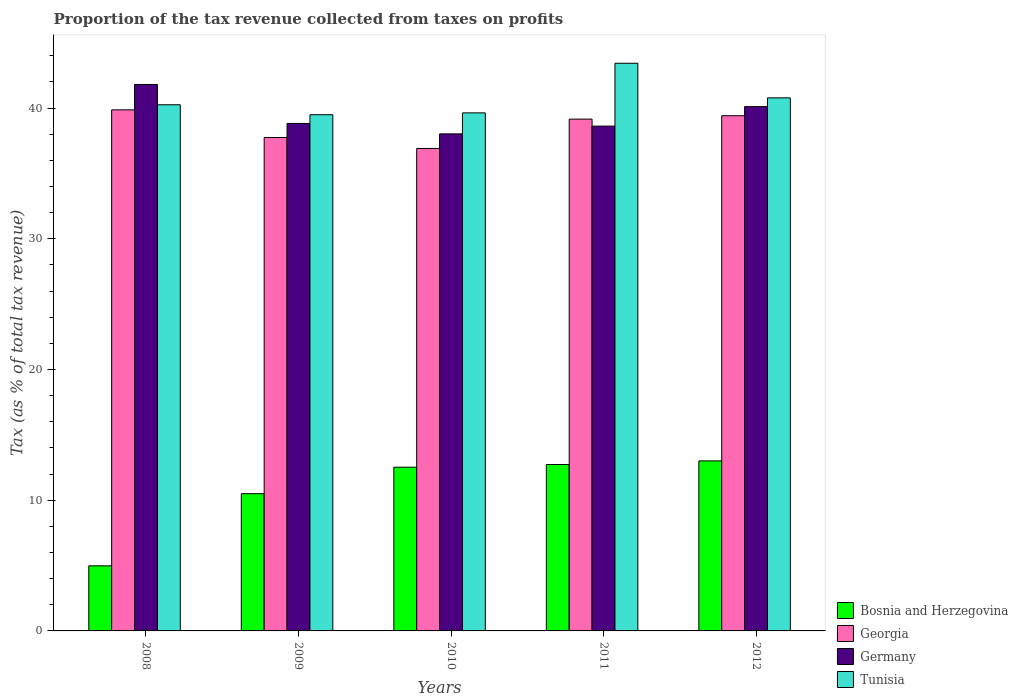How many bars are there on the 5th tick from the left?
Provide a short and direct response. 4. What is the label of the 2nd group of bars from the left?
Offer a terse response. 2009. What is the proportion of the tax revenue collected in Georgia in 2011?
Provide a short and direct response. 39.15. Across all years, what is the maximum proportion of the tax revenue collected in Georgia?
Make the answer very short. 39.86. Across all years, what is the minimum proportion of the tax revenue collected in Georgia?
Make the answer very short. 36.91. What is the total proportion of the tax revenue collected in Bosnia and Herzegovina in the graph?
Your answer should be very brief. 53.74. What is the difference between the proportion of the tax revenue collected in Tunisia in 2008 and that in 2009?
Your answer should be compact. 0.76. What is the difference between the proportion of the tax revenue collected in Georgia in 2008 and the proportion of the tax revenue collected in Tunisia in 2012?
Your answer should be very brief. -0.92. What is the average proportion of the tax revenue collected in Germany per year?
Make the answer very short. 39.48. In the year 2012, what is the difference between the proportion of the tax revenue collected in Georgia and proportion of the tax revenue collected in Bosnia and Herzegovina?
Give a very brief answer. 26.41. What is the ratio of the proportion of the tax revenue collected in Germany in 2009 to that in 2011?
Your answer should be very brief. 1.01. Is the proportion of the tax revenue collected in Georgia in 2008 less than that in 2009?
Your answer should be compact. No. Is the difference between the proportion of the tax revenue collected in Georgia in 2008 and 2011 greater than the difference between the proportion of the tax revenue collected in Bosnia and Herzegovina in 2008 and 2011?
Keep it short and to the point. Yes. What is the difference between the highest and the second highest proportion of the tax revenue collected in Tunisia?
Keep it short and to the point. 2.65. What is the difference between the highest and the lowest proportion of the tax revenue collected in Germany?
Keep it short and to the point. 3.78. In how many years, is the proportion of the tax revenue collected in Germany greater than the average proportion of the tax revenue collected in Germany taken over all years?
Make the answer very short. 2. What does the 3rd bar from the left in 2011 represents?
Your answer should be compact. Germany. What does the 1st bar from the right in 2012 represents?
Make the answer very short. Tunisia. Are all the bars in the graph horizontal?
Your response must be concise. No. Does the graph contain grids?
Offer a very short reply. No. How many legend labels are there?
Offer a terse response. 4. What is the title of the graph?
Your answer should be compact. Proportion of the tax revenue collected from taxes on profits. What is the label or title of the X-axis?
Your answer should be very brief. Years. What is the label or title of the Y-axis?
Offer a terse response. Tax (as % of total tax revenue). What is the Tax (as % of total tax revenue) in Bosnia and Herzegovina in 2008?
Ensure brevity in your answer.  4.98. What is the Tax (as % of total tax revenue) of Georgia in 2008?
Your answer should be very brief. 39.86. What is the Tax (as % of total tax revenue) of Germany in 2008?
Your response must be concise. 41.8. What is the Tax (as % of total tax revenue) of Tunisia in 2008?
Provide a short and direct response. 40.25. What is the Tax (as % of total tax revenue) in Bosnia and Herzegovina in 2009?
Your answer should be compact. 10.5. What is the Tax (as % of total tax revenue) in Georgia in 2009?
Provide a short and direct response. 37.75. What is the Tax (as % of total tax revenue) of Germany in 2009?
Ensure brevity in your answer.  38.82. What is the Tax (as % of total tax revenue) in Tunisia in 2009?
Keep it short and to the point. 39.49. What is the Tax (as % of total tax revenue) in Bosnia and Herzegovina in 2010?
Offer a very short reply. 12.52. What is the Tax (as % of total tax revenue) of Georgia in 2010?
Offer a terse response. 36.91. What is the Tax (as % of total tax revenue) of Germany in 2010?
Offer a very short reply. 38.03. What is the Tax (as % of total tax revenue) in Tunisia in 2010?
Your answer should be compact. 39.63. What is the Tax (as % of total tax revenue) of Bosnia and Herzegovina in 2011?
Your answer should be compact. 12.73. What is the Tax (as % of total tax revenue) in Georgia in 2011?
Ensure brevity in your answer.  39.15. What is the Tax (as % of total tax revenue) of Germany in 2011?
Provide a short and direct response. 38.62. What is the Tax (as % of total tax revenue) of Tunisia in 2011?
Provide a short and direct response. 43.43. What is the Tax (as % of total tax revenue) in Bosnia and Herzegovina in 2012?
Your answer should be very brief. 13.01. What is the Tax (as % of total tax revenue) of Georgia in 2012?
Make the answer very short. 39.41. What is the Tax (as % of total tax revenue) in Germany in 2012?
Your response must be concise. 40.11. What is the Tax (as % of total tax revenue) in Tunisia in 2012?
Your answer should be compact. 40.78. Across all years, what is the maximum Tax (as % of total tax revenue) in Bosnia and Herzegovina?
Offer a very short reply. 13.01. Across all years, what is the maximum Tax (as % of total tax revenue) in Georgia?
Offer a very short reply. 39.86. Across all years, what is the maximum Tax (as % of total tax revenue) of Germany?
Keep it short and to the point. 41.8. Across all years, what is the maximum Tax (as % of total tax revenue) of Tunisia?
Give a very brief answer. 43.43. Across all years, what is the minimum Tax (as % of total tax revenue) in Bosnia and Herzegovina?
Your answer should be very brief. 4.98. Across all years, what is the minimum Tax (as % of total tax revenue) in Georgia?
Provide a short and direct response. 36.91. Across all years, what is the minimum Tax (as % of total tax revenue) of Germany?
Provide a short and direct response. 38.03. Across all years, what is the minimum Tax (as % of total tax revenue) in Tunisia?
Ensure brevity in your answer.  39.49. What is the total Tax (as % of total tax revenue) of Bosnia and Herzegovina in the graph?
Make the answer very short. 53.74. What is the total Tax (as % of total tax revenue) in Georgia in the graph?
Provide a succinct answer. 193.08. What is the total Tax (as % of total tax revenue) in Germany in the graph?
Offer a terse response. 197.38. What is the total Tax (as % of total tax revenue) in Tunisia in the graph?
Your answer should be compact. 203.58. What is the difference between the Tax (as % of total tax revenue) in Bosnia and Herzegovina in 2008 and that in 2009?
Provide a succinct answer. -5.52. What is the difference between the Tax (as % of total tax revenue) of Georgia in 2008 and that in 2009?
Give a very brief answer. 2.12. What is the difference between the Tax (as % of total tax revenue) in Germany in 2008 and that in 2009?
Offer a very short reply. 2.98. What is the difference between the Tax (as % of total tax revenue) in Tunisia in 2008 and that in 2009?
Provide a short and direct response. 0.76. What is the difference between the Tax (as % of total tax revenue) in Bosnia and Herzegovina in 2008 and that in 2010?
Your answer should be compact. -7.54. What is the difference between the Tax (as % of total tax revenue) in Georgia in 2008 and that in 2010?
Your response must be concise. 2.95. What is the difference between the Tax (as % of total tax revenue) of Germany in 2008 and that in 2010?
Ensure brevity in your answer.  3.78. What is the difference between the Tax (as % of total tax revenue) in Tunisia in 2008 and that in 2010?
Your answer should be compact. 0.62. What is the difference between the Tax (as % of total tax revenue) of Bosnia and Herzegovina in 2008 and that in 2011?
Give a very brief answer. -7.75. What is the difference between the Tax (as % of total tax revenue) of Georgia in 2008 and that in 2011?
Offer a terse response. 0.71. What is the difference between the Tax (as % of total tax revenue) in Germany in 2008 and that in 2011?
Your answer should be very brief. 3.19. What is the difference between the Tax (as % of total tax revenue) of Tunisia in 2008 and that in 2011?
Your response must be concise. -3.18. What is the difference between the Tax (as % of total tax revenue) in Bosnia and Herzegovina in 2008 and that in 2012?
Give a very brief answer. -8.03. What is the difference between the Tax (as % of total tax revenue) of Georgia in 2008 and that in 2012?
Give a very brief answer. 0.45. What is the difference between the Tax (as % of total tax revenue) in Germany in 2008 and that in 2012?
Provide a short and direct response. 1.7. What is the difference between the Tax (as % of total tax revenue) of Tunisia in 2008 and that in 2012?
Make the answer very short. -0.53. What is the difference between the Tax (as % of total tax revenue) in Bosnia and Herzegovina in 2009 and that in 2010?
Keep it short and to the point. -2.02. What is the difference between the Tax (as % of total tax revenue) in Georgia in 2009 and that in 2010?
Your answer should be very brief. 0.84. What is the difference between the Tax (as % of total tax revenue) in Germany in 2009 and that in 2010?
Your response must be concise. 0.8. What is the difference between the Tax (as % of total tax revenue) of Tunisia in 2009 and that in 2010?
Your answer should be very brief. -0.14. What is the difference between the Tax (as % of total tax revenue) in Bosnia and Herzegovina in 2009 and that in 2011?
Offer a very short reply. -2.23. What is the difference between the Tax (as % of total tax revenue) in Georgia in 2009 and that in 2011?
Offer a terse response. -1.41. What is the difference between the Tax (as % of total tax revenue) in Germany in 2009 and that in 2011?
Provide a short and direct response. 0.2. What is the difference between the Tax (as % of total tax revenue) in Tunisia in 2009 and that in 2011?
Your answer should be compact. -3.94. What is the difference between the Tax (as % of total tax revenue) in Bosnia and Herzegovina in 2009 and that in 2012?
Your answer should be compact. -2.51. What is the difference between the Tax (as % of total tax revenue) of Georgia in 2009 and that in 2012?
Give a very brief answer. -1.67. What is the difference between the Tax (as % of total tax revenue) in Germany in 2009 and that in 2012?
Make the answer very short. -1.29. What is the difference between the Tax (as % of total tax revenue) of Tunisia in 2009 and that in 2012?
Give a very brief answer. -1.29. What is the difference between the Tax (as % of total tax revenue) of Bosnia and Herzegovina in 2010 and that in 2011?
Ensure brevity in your answer.  -0.21. What is the difference between the Tax (as % of total tax revenue) of Georgia in 2010 and that in 2011?
Offer a very short reply. -2.24. What is the difference between the Tax (as % of total tax revenue) of Germany in 2010 and that in 2011?
Give a very brief answer. -0.59. What is the difference between the Tax (as % of total tax revenue) of Tunisia in 2010 and that in 2011?
Your answer should be very brief. -3.8. What is the difference between the Tax (as % of total tax revenue) in Bosnia and Herzegovina in 2010 and that in 2012?
Provide a succinct answer. -0.48. What is the difference between the Tax (as % of total tax revenue) of Georgia in 2010 and that in 2012?
Make the answer very short. -2.5. What is the difference between the Tax (as % of total tax revenue) in Germany in 2010 and that in 2012?
Provide a succinct answer. -2.08. What is the difference between the Tax (as % of total tax revenue) of Tunisia in 2010 and that in 2012?
Provide a succinct answer. -1.15. What is the difference between the Tax (as % of total tax revenue) in Bosnia and Herzegovina in 2011 and that in 2012?
Keep it short and to the point. -0.27. What is the difference between the Tax (as % of total tax revenue) of Georgia in 2011 and that in 2012?
Offer a terse response. -0.26. What is the difference between the Tax (as % of total tax revenue) in Germany in 2011 and that in 2012?
Your answer should be compact. -1.49. What is the difference between the Tax (as % of total tax revenue) in Tunisia in 2011 and that in 2012?
Your response must be concise. 2.65. What is the difference between the Tax (as % of total tax revenue) in Bosnia and Herzegovina in 2008 and the Tax (as % of total tax revenue) in Georgia in 2009?
Keep it short and to the point. -32.77. What is the difference between the Tax (as % of total tax revenue) in Bosnia and Herzegovina in 2008 and the Tax (as % of total tax revenue) in Germany in 2009?
Offer a very short reply. -33.84. What is the difference between the Tax (as % of total tax revenue) in Bosnia and Herzegovina in 2008 and the Tax (as % of total tax revenue) in Tunisia in 2009?
Offer a terse response. -34.51. What is the difference between the Tax (as % of total tax revenue) of Georgia in 2008 and the Tax (as % of total tax revenue) of Germany in 2009?
Your answer should be very brief. 1.04. What is the difference between the Tax (as % of total tax revenue) in Georgia in 2008 and the Tax (as % of total tax revenue) in Tunisia in 2009?
Give a very brief answer. 0.37. What is the difference between the Tax (as % of total tax revenue) in Germany in 2008 and the Tax (as % of total tax revenue) in Tunisia in 2009?
Offer a very short reply. 2.31. What is the difference between the Tax (as % of total tax revenue) of Bosnia and Herzegovina in 2008 and the Tax (as % of total tax revenue) of Georgia in 2010?
Make the answer very short. -31.93. What is the difference between the Tax (as % of total tax revenue) of Bosnia and Herzegovina in 2008 and the Tax (as % of total tax revenue) of Germany in 2010?
Your response must be concise. -33.05. What is the difference between the Tax (as % of total tax revenue) in Bosnia and Herzegovina in 2008 and the Tax (as % of total tax revenue) in Tunisia in 2010?
Keep it short and to the point. -34.65. What is the difference between the Tax (as % of total tax revenue) in Georgia in 2008 and the Tax (as % of total tax revenue) in Germany in 2010?
Provide a short and direct response. 1.84. What is the difference between the Tax (as % of total tax revenue) of Georgia in 2008 and the Tax (as % of total tax revenue) of Tunisia in 2010?
Your answer should be compact. 0.23. What is the difference between the Tax (as % of total tax revenue) of Germany in 2008 and the Tax (as % of total tax revenue) of Tunisia in 2010?
Keep it short and to the point. 2.17. What is the difference between the Tax (as % of total tax revenue) in Bosnia and Herzegovina in 2008 and the Tax (as % of total tax revenue) in Georgia in 2011?
Your answer should be compact. -34.17. What is the difference between the Tax (as % of total tax revenue) in Bosnia and Herzegovina in 2008 and the Tax (as % of total tax revenue) in Germany in 2011?
Provide a succinct answer. -33.64. What is the difference between the Tax (as % of total tax revenue) in Bosnia and Herzegovina in 2008 and the Tax (as % of total tax revenue) in Tunisia in 2011?
Offer a terse response. -38.45. What is the difference between the Tax (as % of total tax revenue) in Georgia in 2008 and the Tax (as % of total tax revenue) in Germany in 2011?
Your answer should be compact. 1.24. What is the difference between the Tax (as % of total tax revenue) in Georgia in 2008 and the Tax (as % of total tax revenue) in Tunisia in 2011?
Give a very brief answer. -3.56. What is the difference between the Tax (as % of total tax revenue) of Germany in 2008 and the Tax (as % of total tax revenue) of Tunisia in 2011?
Provide a succinct answer. -1.62. What is the difference between the Tax (as % of total tax revenue) of Bosnia and Herzegovina in 2008 and the Tax (as % of total tax revenue) of Georgia in 2012?
Offer a terse response. -34.43. What is the difference between the Tax (as % of total tax revenue) in Bosnia and Herzegovina in 2008 and the Tax (as % of total tax revenue) in Germany in 2012?
Give a very brief answer. -35.13. What is the difference between the Tax (as % of total tax revenue) in Bosnia and Herzegovina in 2008 and the Tax (as % of total tax revenue) in Tunisia in 2012?
Your response must be concise. -35.8. What is the difference between the Tax (as % of total tax revenue) in Georgia in 2008 and the Tax (as % of total tax revenue) in Germany in 2012?
Keep it short and to the point. -0.25. What is the difference between the Tax (as % of total tax revenue) of Georgia in 2008 and the Tax (as % of total tax revenue) of Tunisia in 2012?
Ensure brevity in your answer.  -0.92. What is the difference between the Tax (as % of total tax revenue) in Germany in 2008 and the Tax (as % of total tax revenue) in Tunisia in 2012?
Ensure brevity in your answer.  1.02. What is the difference between the Tax (as % of total tax revenue) in Bosnia and Herzegovina in 2009 and the Tax (as % of total tax revenue) in Georgia in 2010?
Keep it short and to the point. -26.41. What is the difference between the Tax (as % of total tax revenue) in Bosnia and Herzegovina in 2009 and the Tax (as % of total tax revenue) in Germany in 2010?
Make the answer very short. -27.53. What is the difference between the Tax (as % of total tax revenue) in Bosnia and Herzegovina in 2009 and the Tax (as % of total tax revenue) in Tunisia in 2010?
Offer a terse response. -29.13. What is the difference between the Tax (as % of total tax revenue) of Georgia in 2009 and the Tax (as % of total tax revenue) of Germany in 2010?
Make the answer very short. -0.28. What is the difference between the Tax (as % of total tax revenue) in Georgia in 2009 and the Tax (as % of total tax revenue) in Tunisia in 2010?
Your answer should be compact. -1.89. What is the difference between the Tax (as % of total tax revenue) in Germany in 2009 and the Tax (as % of total tax revenue) in Tunisia in 2010?
Provide a short and direct response. -0.81. What is the difference between the Tax (as % of total tax revenue) of Bosnia and Herzegovina in 2009 and the Tax (as % of total tax revenue) of Georgia in 2011?
Provide a succinct answer. -28.65. What is the difference between the Tax (as % of total tax revenue) of Bosnia and Herzegovina in 2009 and the Tax (as % of total tax revenue) of Germany in 2011?
Provide a succinct answer. -28.12. What is the difference between the Tax (as % of total tax revenue) of Bosnia and Herzegovina in 2009 and the Tax (as % of total tax revenue) of Tunisia in 2011?
Give a very brief answer. -32.93. What is the difference between the Tax (as % of total tax revenue) in Georgia in 2009 and the Tax (as % of total tax revenue) in Germany in 2011?
Provide a succinct answer. -0.87. What is the difference between the Tax (as % of total tax revenue) of Georgia in 2009 and the Tax (as % of total tax revenue) of Tunisia in 2011?
Your answer should be compact. -5.68. What is the difference between the Tax (as % of total tax revenue) in Germany in 2009 and the Tax (as % of total tax revenue) in Tunisia in 2011?
Make the answer very short. -4.6. What is the difference between the Tax (as % of total tax revenue) of Bosnia and Herzegovina in 2009 and the Tax (as % of total tax revenue) of Georgia in 2012?
Your answer should be compact. -28.91. What is the difference between the Tax (as % of total tax revenue) in Bosnia and Herzegovina in 2009 and the Tax (as % of total tax revenue) in Germany in 2012?
Your response must be concise. -29.61. What is the difference between the Tax (as % of total tax revenue) in Bosnia and Herzegovina in 2009 and the Tax (as % of total tax revenue) in Tunisia in 2012?
Provide a succinct answer. -30.28. What is the difference between the Tax (as % of total tax revenue) of Georgia in 2009 and the Tax (as % of total tax revenue) of Germany in 2012?
Make the answer very short. -2.36. What is the difference between the Tax (as % of total tax revenue) of Georgia in 2009 and the Tax (as % of total tax revenue) of Tunisia in 2012?
Provide a succinct answer. -3.03. What is the difference between the Tax (as % of total tax revenue) in Germany in 2009 and the Tax (as % of total tax revenue) in Tunisia in 2012?
Provide a succinct answer. -1.96. What is the difference between the Tax (as % of total tax revenue) in Bosnia and Herzegovina in 2010 and the Tax (as % of total tax revenue) in Georgia in 2011?
Give a very brief answer. -26.63. What is the difference between the Tax (as % of total tax revenue) of Bosnia and Herzegovina in 2010 and the Tax (as % of total tax revenue) of Germany in 2011?
Offer a very short reply. -26.09. What is the difference between the Tax (as % of total tax revenue) of Bosnia and Herzegovina in 2010 and the Tax (as % of total tax revenue) of Tunisia in 2011?
Make the answer very short. -30.9. What is the difference between the Tax (as % of total tax revenue) of Georgia in 2010 and the Tax (as % of total tax revenue) of Germany in 2011?
Keep it short and to the point. -1.71. What is the difference between the Tax (as % of total tax revenue) in Georgia in 2010 and the Tax (as % of total tax revenue) in Tunisia in 2011?
Give a very brief answer. -6.52. What is the difference between the Tax (as % of total tax revenue) in Germany in 2010 and the Tax (as % of total tax revenue) in Tunisia in 2011?
Your answer should be compact. -5.4. What is the difference between the Tax (as % of total tax revenue) in Bosnia and Herzegovina in 2010 and the Tax (as % of total tax revenue) in Georgia in 2012?
Provide a short and direct response. -26.89. What is the difference between the Tax (as % of total tax revenue) in Bosnia and Herzegovina in 2010 and the Tax (as % of total tax revenue) in Germany in 2012?
Provide a short and direct response. -27.58. What is the difference between the Tax (as % of total tax revenue) of Bosnia and Herzegovina in 2010 and the Tax (as % of total tax revenue) of Tunisia in 2012?
Ensure brevity in your answer.  -28.26. What is the difference between the Tax (as % of total tax revenue) in Georgia in 2010 and the Tax (as % of total tax revenue) in Germany in 2012?
Keep it short and to the point. -3.2. What is the difference between the Tax (as % of total tax revenue) of Georgia in 2010 and the Tax (as % of total tax revenue) of Tunisia in 2012?
Ensure brevity in your answer.  -3.87. What is the difference between the Tax (as % of total tax revenue) of Germany in 2010 and the Tax (as % of total tax revenue) of Tunisia in 2012?
Provide a succinct answer. -2.76. What is the difference between the Tax (as % of total tax revenue) in Bosnia and Herzegovina in 2011 and the Tax (as % of total tax revenue) in Georgia in 2012?
Ensure brevity in your answer.  -26.68. What is the difference between the Tax (as % of total tax revenue) in Bosnia and Herzegovina in 2011 and the Tax (as % of total tax revenue) in Germany in 2012?
Make the answer very short. -27.38. What is the difference between the Tax (as % of total tax revenue) in Bosnia and Herzegovina in 2011 and the Tax (as % of total tax revenue) in Tunisia in 2012?
Offer a very short reply. -28.05. What is the difference between the Tax (as % of total tax revenue) of Georgia in 2011 and the Tax (as % of total tax revenue) of Germany in 2012?
Provide a short and direct response. -0.95. What is the difference between the Tax (as % of total tax revenue) of Georgia in 2011 and the Tax (as % of total tax revenue) of Tunisia in 2012?
Your answer should be compact. -1.63. What is the difference between the Tax (as % of total tax revenue) of Germany in 2011 and the Tax (as % of total tax revenue) of Tunisia in 2012?
Make the answer very short. -2.16. What is the average Tax (as % of total tax revenue) of Bosnia and Herzegovina per year?
Offer a very short reply. 10.75. What is the average Tax (as % of total tax revenue) in Georgia per year?
Your answer should be very brief. 38.62. What is the average Tax (as % of total tax revenue) of Germany per year?
Provide a short and direct response. 39.48. What is the average Tax (as % of total tax revenue) of Tunisia per year?
Provide a short and direct response. 40.72. In the year 2008, what is the difference between the Tax (as % of total tax revenue) in Bosnia and Herzegovina and Tax (as % of total tax revenue) in Georgia?
Offer a very short reply. -34.88. In the year 2008, what is the difference between the Tax (as % of total tax revenue) of Bosnia and Herzegovina and Tax (as % of total tax revenue) of Germany?
Your answer should be very brief. -36.82. In the year 2008, what is the difference between the Tax (as % of total tax revenue) of Bosnia and Herzegovina and Tax (as % of total tax revenue) of Tunisia?
Your response must be concise. -35.27. In the year 2008, what is the difference between the Tax (as % of total tax revenue) of Georgia and Tax (as % of total tax revenue) of Germany?
Keep it short and to the point. -1.94. In the year 2008, what is the difference between the Tax (as % of total tax revenue) of Georgia and Tax (as % of total tax revenue) of Tunisia?
Ensure brevity in your answer.  -0.39. In the year 2008, what is the difference between the Tax (as % of total tax revenue) in Germany and Tax (as % of total tax revenue) in Tunisia?
Ensure brevity in your answer.  1.55. In the year 2009, what is the difference between the Tax (as % of total tax revenue) in Bosnia and Herzegovina and Tax (as % of total tax revenue) in Georgia?
Your answer should be compact. -27.25. In the year 2009, what is the difference between the Tax (as % of total tax revenue) of Bosnia and Herzegovina and Tax (as % of total tax revenue) of Germany?
Offer a terse response. -28.32. In the year 2009, what is the difference between the Tax (as % of total tax revenue) of Bosnia and Herzegovina and Tax (as % of total tax revenue) of Tunisia?
Keep it short and to the point. -28.99. In the year 2009, what is the difference between the Tax (as % of total tax revenue) in Georgia and Tax (as % of total tax revenue) in Germany?
Provide a succinct answer. -1.08. In the year 2009, what is the difference between the Tax (as % of total tax revenue) of Georgia and Tax (as % of total tax revenue) of Tunisia?
Offer a terse response. -1.74. In the year 2009, what is the difference between the Tax (as % of total tax revenue) in Germany and Tax (as % of total tax revenue) in Tunisia?
Your answer should be compact. -0.67. In the year 2010, what is the difference between the Tax (as % of total tax revenue) in Bosnia and Herzegovina and Tax (as % of total tax revenue) in Georgia?
Make the answer very short. -24.38. In the year 2010, what is the difference between the Tax (as % of total tax revenue) in Bosnia and Herzegovina and Tax (as % of total tax revenue) in Germany?
Provide a succinct answer. -25.5. In the year 2010, what is the difference between the Tax (as % of total tax revenue) in Bosnia and Herzegovina and Tax (as % of total tax revenue) in Tunisia?
Provide a short and direct response. -27.11. In the year 2010, what is the difference between the Tax (as % of total tax revenue) in Georgia and Tax (as % of total tax revenue) in Germany?
Offer a terse response. -1.12. In the year 2010, what is the difference between the Tax (as % of total tax revenue) in Georgia and Tax (as % of total tax revenue) in Tunisia?
Provide a succinct answer. -2.72. In the year 2010, what is the difference between the Tax (as % of total tax revenue) in Germany and Tax (as % of total tax revenue) in Tunisia?
Give a very brief answer. -1.61. In the year 2011, what is the difference between the Tax (as % of total tax revenue) of Bosnia and Herzegovina and Tax (as % of total tax revenue) of Georgia?
Ensure brevity in your answer.  -26.42. In the year 2011, what is the difference between the Tax (as % of total tax revenue) of Bosnia and Herzegovina and Tax (as % of total tax revenue) of Germany?
Provide a short and direct response. -25.89. In the year 2011, what is the difference between the Tax (as % of total tax revenue) of Bosnia and Herzegovina and Tax (as % of total tax revenue) of Tunisia?
Make the answer very short. -30.69. In the year 2011, what is the difference between the Tax (as % of total tax revenue) in Georgia and Tax (as % of total tax revenue) in Germany?
Make the answer very short. 0.54. In the year 2011, what is the difference between the Tax (as % of total tax revenue) of Georgia and Tax (as % of total tax revenue) of Tunisia?
Your response must be concise. -4.27. In the year 2011, what is the difference between the Tax (as % of total tax revenue) in Germany and Tax (as % of total tax revenue) in Tunisia?
Ensure brevity in your answer.  -4.81. In the year 2012, what is the difference between the Tax (as % of total tax revenue) in Bosnia and Herzegovina and Tax (as % of total tax revenue) in Georgia?
Make the answer very short. -26.41. In the year 2012, what is the difference between the Tax (as % of total tax revenue) in Bosnia and Herzegovina and Tax (as % of total tax revenue) in Germany?
Give a very brief answer. -27.1. In the year 2012, what is the difference between the Tax (as % of total tax revenue) in Bosnia and Herzegovina and Tax (as % of total tax revenue) in Tunisia?
Keep it short and to the point. -27.77. In the year 2012, what is the difference between the Tax (as % of total tax revenue) in Georgia and Tax (as % of total tax revenue) in Germany?
Keep it short and to the point. -0.7. In the year 2012, what is the difference between the Tax (as % of total tax revenue) of Georgia and Tax (as % of total tax revenue) of Tunisia?
Your answer should be very brief. -1.37. In the year 2012, what is the difference between the Tax (as % of total tax revenue) of Germany and Tax (as % of total tax revenue) of Tunisia?
Offer a terse response. -0.67. What is the ratio of the Tax (as % of total tax revenue) in Bosnia and Herzegovina in 2008 to that in 2009?
Your answer should be very brief. 0.47. What is the ratio of the Tax (as % of total tax revenue) in Georgia in 2008 to that in 2009?
Your answer should be very brief. 1.06. What is the ratio of the Tax (as % of total tax revenue) of Germany in 2008 to that in 2009?
Your answer should be very brief. 1.08. What is the ratio of the Tax (as % of total tax revenue) in Tunisia in 2008 to that in 2009?
Provide a succinct answer. 1.02. What is the ratio of the Tax (as % of total tax revenue) of Bosnia and Herzegovina in 2008 to that in 2010?
Your answer should be compact. 0.4. What is the ratio of the Tax (as % of total tax revenue) in Germany in 2008 to that in 2010?
Make the answer very short. 1.1. What is the ratio of the Tax (as % of total tax revenue) in Tunisia in 2008 to that in 2010?
Your answer should be compact. 1.02. What is the ratio of the Tax (as % of total tax revenue) in Bosnia and Herzegovina in 2008 to that in 2011?
Provide a succinct answer. 0.39. What is the ratio of the Tax (as % of total tax revenue) of Georgia in 2008 to that in 2011?
Give a very brief answer. 1.02. What is the ratio of the Tax (as % of total tax revenue) in Germany in 2008 to that in 2011?
Provide a succinct answer. 1.08. What is the ratio of the Tax (as % of total tax revenue) in Tunisia in 2008 to that in 2011?
Keep it short and to the point. 0.93. What is the ratio of the Tax (as % of total tax revenue) in Bosnia and Herzegovina in 2008 to that in 2012?
Provide a succinct answer. 0.38. What is the ratio of the Tax (as % of total tax revenue) in Georgia in 2008 to that in 2012?
Your response must be concise. 1.01. What is the ratio of the Tax (as % of total tax revenue) in Germany in 2008 to that in 2012?
Offer a very short reply. 1.04. What is the ratio of the Tax (as % of total tax revenue) of Tunisia in 2008 to that in 2012?
Make the answer very short. 0.99. What is the ratio of the Tax (as % of total tax revenue) in Bosnia and Herzegovina in 2009 to that in 2010?
Provide a succinct answer. 0.84. What is the ratio of the Tax (as % of total tax revenue) in Georgia in 2009 to that in 2010?
Give a very brief answer. 1.02. What is the ratio of the Tax (as % of total tax revenue) of Bosnia and Herzegovina in 2009 to that in 2011?
Offer a terse response. 0.82. What is the ratio of the Tax (as % of total tax revenue) in Georgia in 2009 to that in 2011?
Offer a very short reply. 0.96. What is the ratio of the Tax (as % of total tax revenue) of Germany in 2009 to that in 2011?
Your answer should be very brief. 1.01. What is the ratio of the Tax (as % of total tax revenue) in Tunisia in 2009 to that in 2011?
Keep it short and to the point. 0.91. What is the ratio of the Tax (as % of total tax revenue) in Bosnia and Herzegovina in 2009 to that in 2012?
Give a very brief answer. 0.81. What is the ratio of the Tax (as % of total tax revenue) of Georgia in 2009 to that in 2012?
Give a very brief answer. 0.96. What is the ratio of the Tax (as % of total tax revenue) in Germany in 2009 to that in 2012?
Your response must be concise. 0.97. What is the ratio of the Tax (as % of total tax revenue) in Tunisia in 2009 to that in 2012?
Ensure brevity in your answer.  0.97. What is the ratio of the Tax (as % of total tax revenue) of Bosnia and Herzegovina in 2010 to that in 2011?
Give a very brief answer. 0.98. What is the ratio of the Tax (as % of total tax revenue) in Georgia in 2010 to that in 2011?
Your response must be concise. 0.94. What is the ratio of the Tax (as % of total tax revenue) in Germany in 2010 to that in 2011?
Your response must be concise. 0.98. What is the ratio of the Tax (as % of total tax revenue) of Tunisia in 2010 to that in 2011?
Your answer should be very brief. 0.91. What is the ratio of the Tax (as % of total tax revenue) of Bosnia and Herzegovina in 2010 to that in 2012?
Provide a succinct answer. 0.96. What is the ratio of the Tax (as % of total tax revenue) of Georgia in 2010 to that in 2012?
Your answer should be very brief. 0.94. What is the ratio of the Tax (as % of total tax revenue) of Germany in 2010 to that in 2012?
Your answer should be compact. 0.95. What is the ratio of the Tax (as % of total tax revenue) of Tunisia in 2010 to that in 2012?
Offer a terse response. 0.97. What is the ratio of the Tax (as % of total tax revenue) of Bosnia and Herzegovina in 2011 to that in 2012?
Your answer should be very brief. 0.98. What is the ratio of the Tax (as % of total tax revenue) in Georgia in 2011 to that in 2012?
Give a very brief answer. 0.99. What is the ratio of the Tax (as % of total tax revenue) in Germany in 2011 to that in 2012?
Provide a succinct answer. 0.96. What is the ratio of the Tax (as % of total tax revenue) in Tunisia in 2011 to that in 2012?
Your answer should be compact. 1.06. What is the difference between the highest and the second highest Tax (as % of total tax revenue) of Bosnia and Herzegovina?
Provide a succinct answer. 0.27. What is the difference between the highest and the second highest Tax (as % of total tax revenue) of Georgia?
Keep it short and to the point. 0.45. What is the difference between the highest and the second highest Tax (as % of total tax revenue) in Germany?
Your response must be concise. 1.7. What is the difference between the highest and the second highest Tax (as % of total tax revenue) in Tunisia?
Keep it short and to the point. 2.65. What is the difference between the highest and the lowest Tax (as % of total tax revenue) of Bosnia and Herzegovina?
Provide a short and direct response. 8.03. What is the difference between the highest and the lowest Tax (as % of total tax revenue) of Georgia?
Keep it short and to the point. 2.95. What is the difference between the highest and the lowest Tax (as % of total tax revenue) of Germany?
Your response must be concise. 3.78. What is the difference between the highest and the lowest Tax (as % of total tax revenue) in Tunisia?
Your response must be concise. 3.94. 